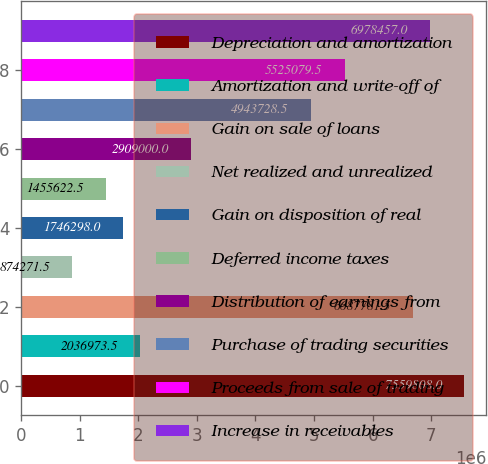Convert chart. <chart><loc_0><loc_0><loc_500><loc_500><bar_chart><fcel>Depreciation and amortization<fcel>Amortization and write-off of<fcel>Gain on sale of loans<fcel>Net realized and unrealized<fcel>Gain on disposition of real<fcel>Deferred income taxes<fcel>Distribution of earnings from<fcel>Purchase of trading securities<fcel>Proceeds from sale of trading<fcel>Increase in receivables<nl><fcel>7.55981e+06<fcel>2.03697e+06<fcel>6.68778e+06<fcel>874272<fcel>1.7463e+06<fcel>1.45562e+06<fcel>2.909e+06<fcel>4.94373e+06<fcel>5.52508e+06<fcel>6.97846e+06<nl></chart> 